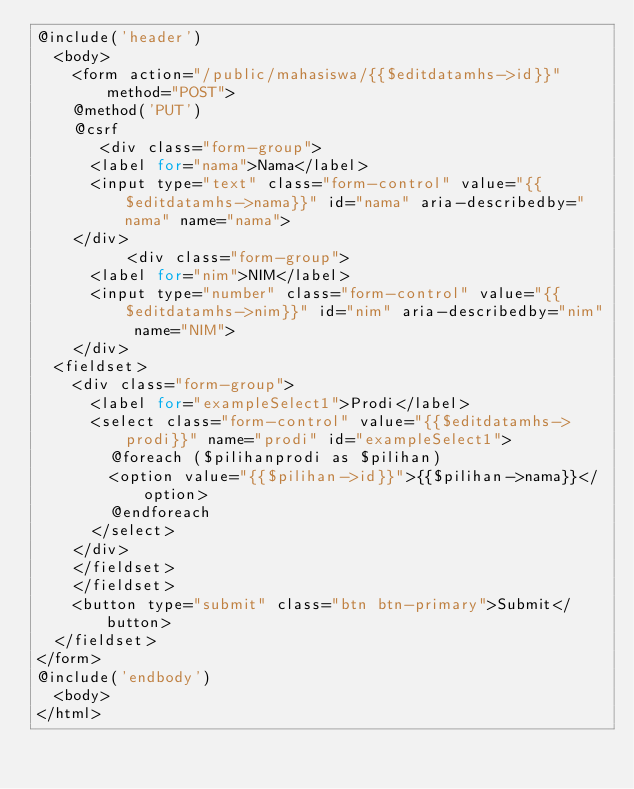<code> <loc_0><loc_0><loc_500><loc_500><_PHP_>@include('header')
	<body>
    <form action="/public/mahasiswa/{{$editdatamhs->id}}" method="POST">
    @method('PUT')
    @csrf
       <div class="form-group">
      <label for="nama">Nama</label>
      <input type="text" class="form-control" value="{{$editdatamhs->nama}}" id="nama" aria-describedby="nama" name="nama">
    </div>
          <div class="form-group">
      <label for="nim">NIM</label>
      <input type="number" class="form-control" value="{{$editdatamhs->nim}}" id="nim" aria-describedby="nim" name="NIM">
    </div>
  <fieldset>
    <div class="form-group">
      <label for="exampleSelect1">Prodi</label>
      <select class="form-control" value="{{$editdatamhs->prodi}}" name="prodi" id="exampleSelect1">
        @foreach ($pilihanprodi as $pilihan)
        <option value="{{$pilihan->id}}">{{$pilihan->nama}}</option>
        @endforeach
      </select>
    </div>
    </fieldset>
    </fieldset>
    <button type="submit" class="btn btn-primary">Submit</button>
  </fieldset>
</form>
@include('endbody')
	<body>
</html></code> 